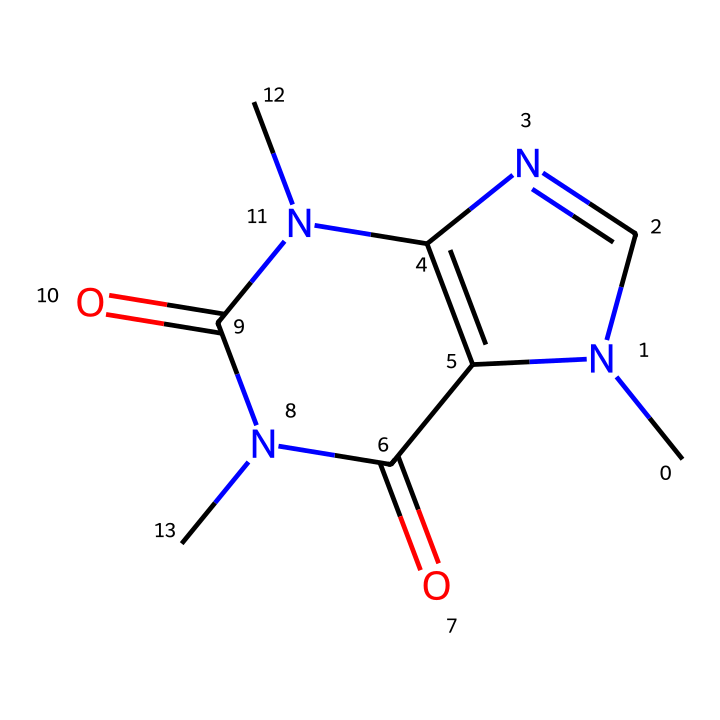What is the molecular formula of caffeine? To determine the molecular formula, identify the number of each type of atom in the chemical structure represented by the SMILES. The structure has 8 carbon (C), 10 hydrogen (H), 4 nitrogen (N), and 2 oxygen (O) atoms. So, the molecular formula is C8H10N4O2.
Answer: C8H10N4O2 How many nitrogen atoms are present in the caffeine structure? By examining the SMILES representation, count the nitrogen symbols (N) in the formula. There are four nitrogen atoms present in the structure of caffeine.
Answer: 4 What type of compound is caffeine? Caffeine is classified as an alkaloid due to the presence of nitrogen atoms which contribute to its physiological effects, particularly as a stimulant.
Answer: alkaloid What is the total number of rings in the caffeine structure? Inspecting the structure, it reveals a fused ring system composed of two rings. Each part of the structure that forms a closed loop indicates a ring.
Answer: 2 Which elements make up the functional groups in caffeine? In caffeine, the functional groups primarily include amine groups (due to the nitrogen atoms) and carbonyl groups (due to the presence of oxygen double bonds), which are critical for its biological function.
Answer: nitrogen and oxygen What characteristic feature of caffeine contributes to its stimulant properties? The presence of multiple nitrogen atoms in the structure allows caffeine to interact with brain receptors, notably adenosine receptors, hence contributing to its stimulant effects.
Answer: nitrogen atoms 